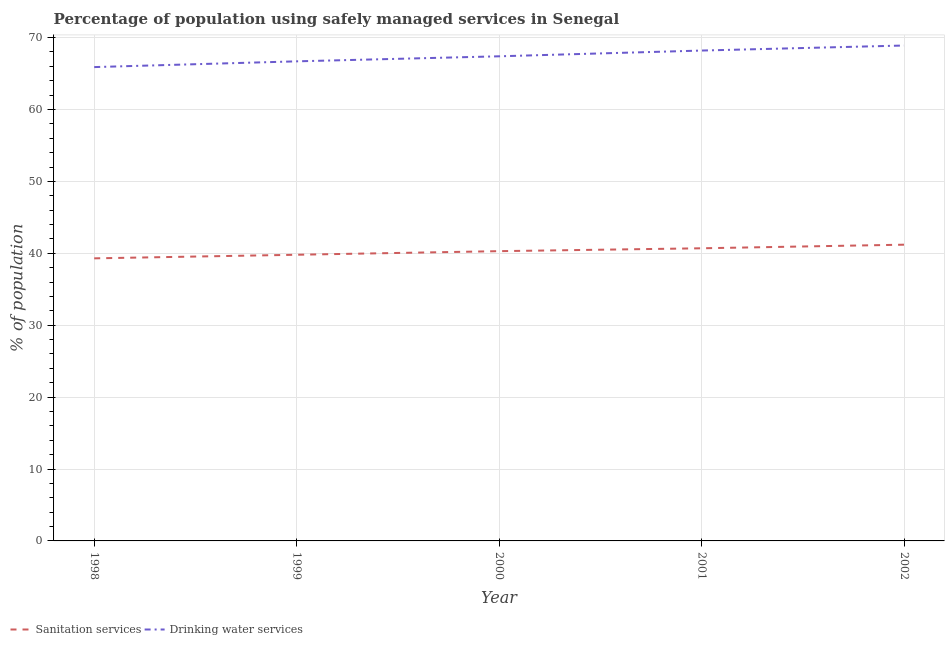What is the percentage of population who used drinking water services in 2000?
Give a very brief answer. 67.4. Across all years, what is the maximum percentage of population who used sanitation services?
Give a very brief answer. 41.2. Across all years, what is the minimum percentage of population who used drinking water services?
Offer a terse response. 65.9. What is the total percentage of population who used drinking water services in the graph?
Your response must be concise. 337.1. What is the difference between the percentage of population who used sanitation services in 1998 and that in 2000?
Ensure brevity in your answer.  -1. What is the difference between the percentage of population who used sanitation services in 1999 and the percentage of population who used drinking water services in 2002?
Your response must be concise. -29.1. What is the average percentage of population who used sanitation services per year?
Your answer should be compact. 40.26. In the year 2001, what is the difference between the percentage of population who used sanitation services and percentage of population who used drinking water services?
Provide a succinct answer. -27.5. What is the ratio of the percentage of population who used sanitation services in 1999 to that in 2000?
Keep it short and to the point. 0.99. What is the difference between the highest and the second highest percentage of population who used drinking water services?
Make the answer very short. 0.7. What is the difference between the highest and the lowest percentage of population who used sanitation services?
Offer a terse response. 1.9. Is the percentage of population who used drinking water services strictly greater than the percentage of population who used sanitation services over the years?
Make the answer very short. Yes. Does the graph contain any zero values?
Keep it short and to the point. No. Where does the legend appear in the graph?
Keep it short and to the point. Bottom left. How are the legend labels stacked?
Ensure brevity in your answer.  Horizontal. What is the title of the graph?
Ensure brevity in your answer.  Percentage of population using safely managed services in Senegal. What is the label or title of the X-axis?
Offer a very short reply. Year. What is the label or title of the Y-axis?
Your answer should be very brief. % of population. What is the % of population of Sanitation services in 1998?
Offer a terse response. 39.3. What is the % of population in Drinking water services in 1998?
Your response must be concise. 65.9. What is the % of population of Sanitation services in 1999?
Offer a very short reply. 39.8. What is the % of population in Drinking water services in 1999?
Give a very brief answer. 66.7. What is the % of population of Sanitation services in 2000?
Give a very brief answer. 40.3. What is the % of population of Drinking water services in 2000?
Give a very brief answer. 67.4. What is the % of population of Sanitation services in 2001?
Your answer should be compact. 40.7. What is the % of population of Drinking water services in 2001?
Your answer should be very brief. 68.2. What is the % of population in Sanitation services in 2002?
Keep it short and to the point. 41.2. What is the % of population in Drinking water services in 2002?
Offer a very short reply. 68.9. Across all years, what is the maximum % of population in Sanitation services?
Your answer should be compact. 41.2. Across all years, what is the maximum % of population of Drinking water services?
Your answer should be compact. 68.9. Across all years, what is the minimum % of population in Sanitation services?
Offer a very short reply. 39.3. Across all years, what is the minimum % of population in Drinking water services?
Keep it short and to the point. 65.9. What is the total % of population of Sanitation services in the graph?
Your answer should be compact. 201.3. What is the total % of population of Drinking water services in the graph?
Your answer should be very brief. 337.1. What is the difference between the % of population of Sanitation services in 1998 and that in 1999?
Make the answer very short. -0.5. What is the difference between the % of population in Sanitation services in 1998 and that in 2000?
Ensure brevity in your answer.  -1. What is the difference between the % of population in Drinking water services in 1998 and that in 2000?
Your answer should be very brief. -1.5. What is the difference between the % of population of Sanitation services in 1998 and that in 2001?
Offer a very short reply. -1.4. What is the difference between the % of population of Sanitation services in 1998 and that in 2002?
Give a very brief answer. -1.9. What is the difference between the % of population in Drinking water services in 1998 and that in 2002?
Provide a short and direct response. -3. What is the difference between the % of population in Drinking water services in 1999 and that in 2000?
Provide a short and direct response. -0.7. What is the difference between the % of population of Drinking water services in 1999 and that in 2001?
Offer a terse response. -1.5. What is the difference between the % of population in Sanitation services in 1999 and that in 2002?
Provide a succinct answer. -1.4. What is the difference between the % of population of Drinking water services in 1999 and that in 2002?
Provide a short and direct response. -2.2. What is the difference between the % of population in Sanitation services in 2000 and that in 2002?
Ensure brevity in your answer.  -0.9. What is the difference between the % of population in Drinking water services in 2001 and that in 2002?
Provide a short and direct response. -0.7. What is the difference between the % of population of Sanitation services in 1998 and the % of population of Drinking water services in 1999?
Your answer should be compact. -27.4. What is the difference between the % of population of Sanitation services in 1998 and the % of population of Drinking water services in 2000?
Ensure brevity in your answer.  -28.1. What is the difference between the % of population of Sanitation services in 1998 and the % of population of Drinking water services in 2001?
Make the answer very short. -28.9. What is the difference between the % of population in Sanitation services in 1998 and the % of population in Drinking water services in 2002?
Offer a terse response. -29.6. What is the difference between the % of population in Sanitation services in 1999 and the % of population in Drinking water services in 2000?
Keep it short and to the point. -27.6. What is the difference between the % of population of Sanitation services in 1999 and the % of population of Drinking water services in 2001?
Your answer should be very brief. -28.4. What is the difference between the % of population of Sanitation services in 1999 and the % of population of Drinking water services in 2002?
Ensure brevity in your answer.  -29.1. What is the difference between the % of population of Sanitation services in 2000 and the % of population of Drinking water services in 2001?
Ensure brevity in your answer.  -27.9. What is the difference between the % of population of Sanitation services in 2000 and the % of population of Drinking water services in 2002?
Provide a short and direct response. -28.6. What is the difference between the % of population in Sanitation services in 2001 and the % of population in Drinking water services in 2002?
Keep it short and to the point. -28.2. What is the average % of population of Sanitation services per year?
Keep it short and to the point. 40.26. What is the average % of population in Drinking water services per year?
Your answer should be very brief. 67.42. In the year 1998, what is the difference between the % of population of Sanitation services and % of population of Drinking water services?
Offer a terse response. -26.6. In the year 1999, what is the difference between the % of population in Sanitation services and % of population in Drinking water services?
Your response must be concise. -26.9. In the year 2000, what is the difference between the % of population of Sanitation services and % of population of Drinking water services?
Provide a succinct answer. -27.1. In the year 2001, what is the difference between the % of population in Sanitation services and % of population in Drinking water services?
Provide a short and direct response. -27.5. In the year 2002, what is the difference between the % of population in Sanitation services and % of population in Drinking water services?
Your answer should be compact. -27.7. What is the ratio of the % of population of Sanitation services in 1998 to that in 1999?
Make the answer very short. 0.99. What is the ratio of the % of population of Drinking water services in 1998 to that in 1999?
Make the answer very short. 0.99. What is the ratio of the % of population in Sanitation services in 1998 to that in 2000?
Your response must be concise. 0.98. What is the ratio of the % of population of Drinking water services in 1998 to that in 2000?
Offer a very short reply. 0.98. What is the ratio of the % of population of Sanitation services in 1998 to that in 2001?
Offer a very short reply. 0.97. What is the ratio of the % of population of Drinking water services in 1998 to that in 2001?
Give a very brief answer. 0.97. What is the ratio of the % of population in Sanitation services in 1998 to that in 2002?
Provide a succinct answer. 0.95. What is the ratio of the % of population in Drinking water services in 1998 to that in 2002?
Your response must be concise. 0.96. What is the ratio of the % of population of Sanitation services in 1999 to that in 2000?
Offer a very short reply. 0.99. What is the ratio of the % of population in Drinking water services in 1999 to that in 2000?
Your answer should be very brief. 0.99. What is the ratio of the % of population in Sanitation services in 1999 to that in 2001?
Your answer should be very brief. 0.98. What is the ratio of the % of population of Drinking water services in 1999 to that in 2002?
Your response must be concise. 0.97. What is the ratio of the % of population of Sanitation services in 2000 to that in 2001?
Provide a succinct answer. 0.99. What is the ratio of the % of population of Drinking water services in 2000 to that in 2001?
Your response must be concise. 0.99. What is the ratio of the % of population in Sanitation services in 2000 to that in 2002?
Keep it short and to the point. 0.98. What is the ratio of the % of population in Drinking water services in 2000 to that in 2002?
Ensure brevity in your answer.  0.98. What is the ratio of the % of population in Sanitation services in 2001 to that in 2002?
Make the answer very short. 0.99. What is the difference between the highest and the second highest % of population of Drinking water services?
Keep it short and to the point. 0.7. What is the difference between the highest and the lowest % of population of Drinking water services?
Provide a succinct answer. 3. 